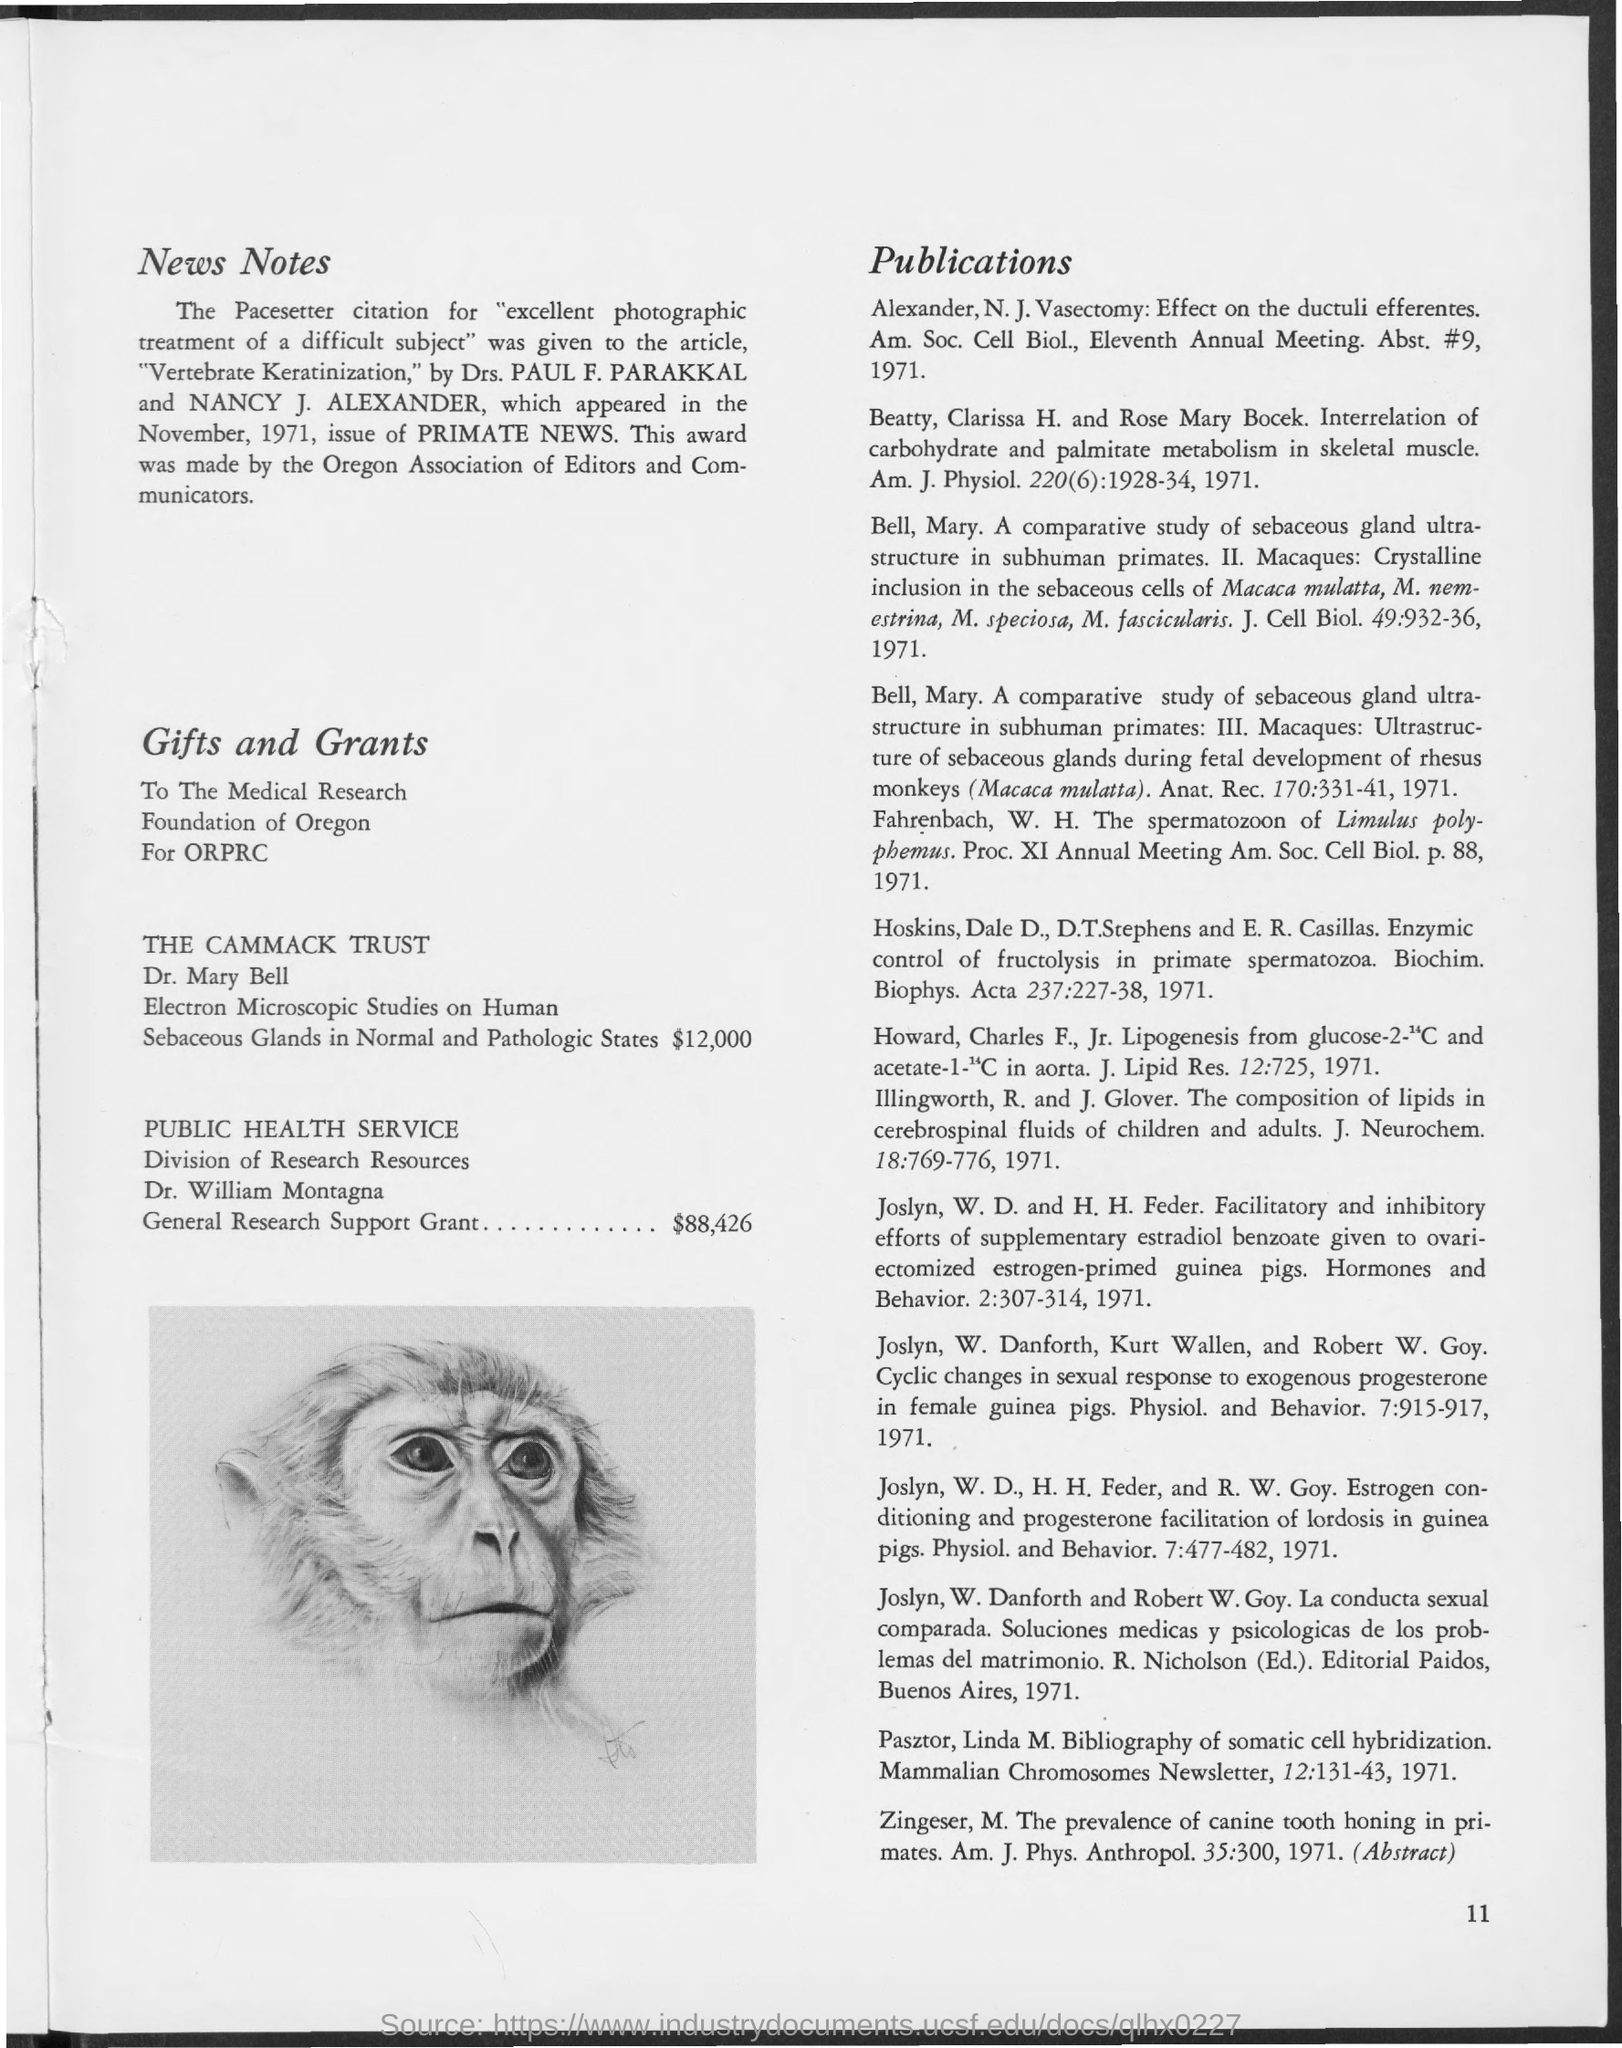Whic article received the Pacesetter citation for "excellent photographic treatment of a difficult subject"?
Ensure brevity in your answer.  "Vertebrate Keratinization". Who are the authors of the article "Vertebrate Keratinization?
Provide a short and direct response. Drs. PAUL F. PARAKKAL and NANCY J. ALEXANDER. Who made this award?
Your answer should be very brief. The oregon association of editors and communicators. Where did the article "Vertebrate Keratinization" appear?
Provide a succinct answer. Primate news. What is the value of General Research Support Grant?
Your response must be concise. $88,426. 